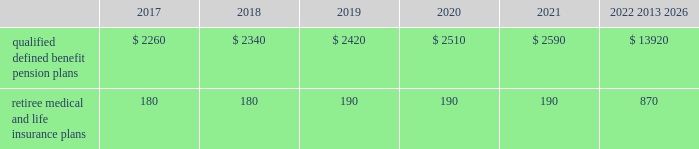Contributions and expected benefit payments the funding of our qualified defined benefit pension plans is determined in accordance with erisa , as amended by the ppa , and in a manner consistent with cas and internal revenue code rules .
There were no contributions to our legacy qualified defined benefit pension plans during 2016 .
We do not plan to make contributions to our legacy pension plans in 2017 because none are required using current assumptions including investment returns on plan assets .
We made $ 23 million in contributions during 2016 to our newly established sikorsky pension plan and expect to make $ 45 million in contributions to this plan during 2017 .
The table presents estimated future benefit payments , which reflect expected future employee service , as of december 31 , 2016 ( in millions ) : .
Defined contribution plans we maintain a number of defined contribution plans , most with 401 ( k ) features , that cover substantially all of our employees .
Under the provisions of our 401 ( k ) plans , we match most employees 2019 eligible contributions at rates specified in the plan documents .
Our contributions were $ 617 million in 2016 , $ 393 million in 2015 and $ 385 million in 2014 , the majority of which were funded in our common stock .
Our defined contribution plans held approximately 36.9 million and 40.0 million shares of our common stock as of december 31 , 2016 and 2015 .
Note 12 2013 stockholders 2019 equity at december 31 , 2016 and 2015 , our authorized capital was composed of 1.5 billion shares of common stock and 50 million shares of series preferred stock .
Of the 290 million shares of common stock issued and outstanding as of december 31 , 2016 , 289 million shares were considered outstanding for consolidated balance sheet presentation purposes ; the remaining shares were held in a separate trust .
Of the 305 million shares of common stock issued and outstanding as of december 31 , 2015 , 303 million shares were considered outstanding for consolidated balance sheet presentation purposes ; the remaining shares were held in a separate trust .
No shares of preferred stock were issued and outstanding at december 31 , 2016 or 2015 .
Repurchases of common stock during 2016 , we repurchased 8.9 million shares of our common stock for $ 2.1 billion .
During 2015 and 2014 , we paid $ 3.1 billion and $ 1.9 billion to repurchase 15.2 million and 11.5 million shares of our common stock .
On september 22 , 2016 , our board of directors approved a $ 2.0 billion increase to our share repurchase program .
Inclusive of this increase , the total remaining authorization for future common share repurchases under our program was $ 3.5 billion as of december 31 , 2016 .
As we repurchase our common shares , we reduce common stock for the $ 1 of par value of the shares repurchased , with the excess purchase price over par value recorded as a reduction of additional paid-in capital .
Due to the volume of repurchases made under our share repurchase program , additional paid-in capital was reduced to zero , with the remainder of the excess purchase price over par value of $ 1.7 billion and $ 2.4 billion recorded as a reduction of retained earnings in 2016 and 2015 .
We paid dividends totaling $ 2.0 billion ( $ 6.77 per share ) in 2016 , $ 1.9 billion ( $ 6.15 per share ) in 2015 and $ 1.8 billion ( $ 5.49 per share ) in 2014 .
We have increased our quarterly dividend rate in each of the last three years , including a 10% ( 10 % ) increase in the quarterly dividend rate in the fourth quarter of 2016 .
We declared quarterly dividends of $ 1.65 per share during each of the first three quarters of 2016 and $ 1.82 per share during the fourth quarter of 2016 ; $ 1.50 per share during each of the first three quarters of 2015 and $ 1.65 per share during the fourth quarter of 2015 ; and $ 1.33 per share during each of the first three quarters of 2014 and $ 1.50 per share during the fourth quarter of 2014. .
What is the change in millions of qualified defined benefit pension plans from 2017 to 2018 in estimated future benefit payments , which reflect expected future employee service , as of december 31 , 2016? 
Computations: (2340 - 2260)
Answer: 80.0. 